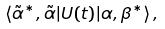Convert formula to latex. <formula><loc_0><loc_0><loc_500><loc_500>\langle \tilde { \alpha } ^ { * } , \tilde { \alpha } | U ( t ) | \alpha , \beta ^ { * } \rangle \, ,</formula> 